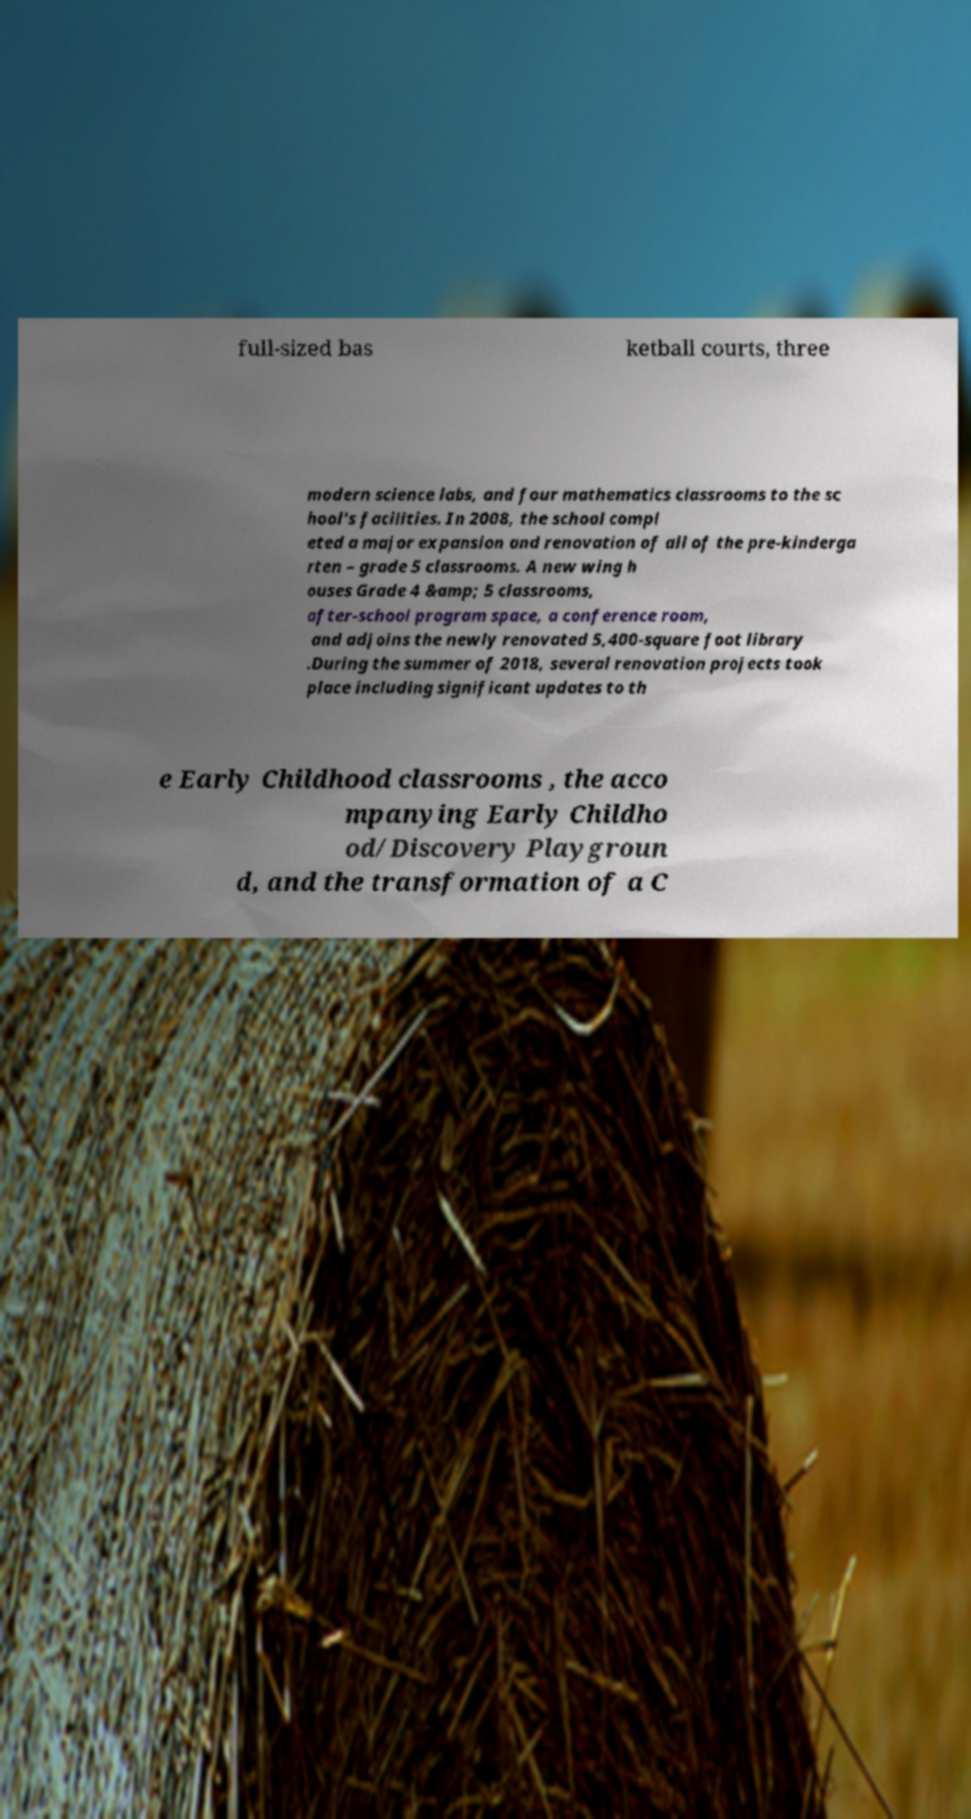Please read and relay the text visible in this image. What does it say? full-sized bas ketball courts, three modern science labs, and four mathematics classrooms to the sc hool's facilities. In 2008, the school compl eted a major expansion and renovation of all of the pre-kinderga rten – grade 5 classrooms. A new wing h ouses Grade 4 &amp; 5 classrooms, after-school program space, a conference room, and adjoins the newly renovated 5,400-square foot library .During the summer of 2018, several renovation projects took place including significant updates to th e Early Childhood classrooms , the acco mpanying Early Childho od/Discovery Playgroun d, and the transformation of a C 